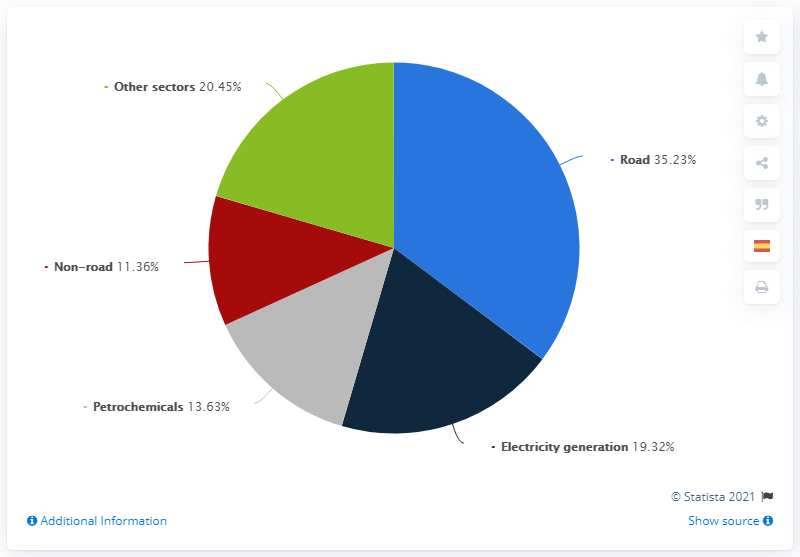Highlight a few significant elements in this photo. Of all the oil consumed by the Organization for Economic Cooperation and Development (OECD), 13.63% is used for petrochemical purposes. 